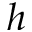<formula> <loc_0><loc_0><loc_500><loc_500>h</formula> 